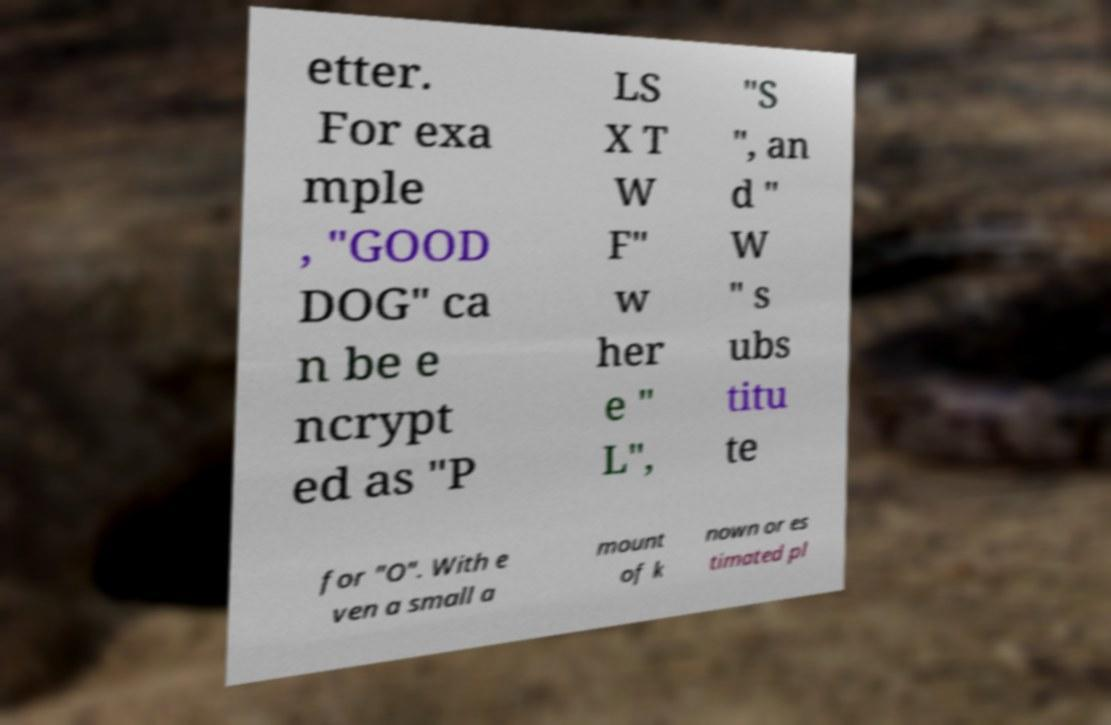Can you accurately transcribe the text from the provided image for me? etter. For exa mple , "GOOD DOG" ca n be e ncrypt ed as "P LS X T W F" w her e " L", "S ", an d " W " s ubs titu te for "O". With e ven a small a mount of k nown or es timated pl 